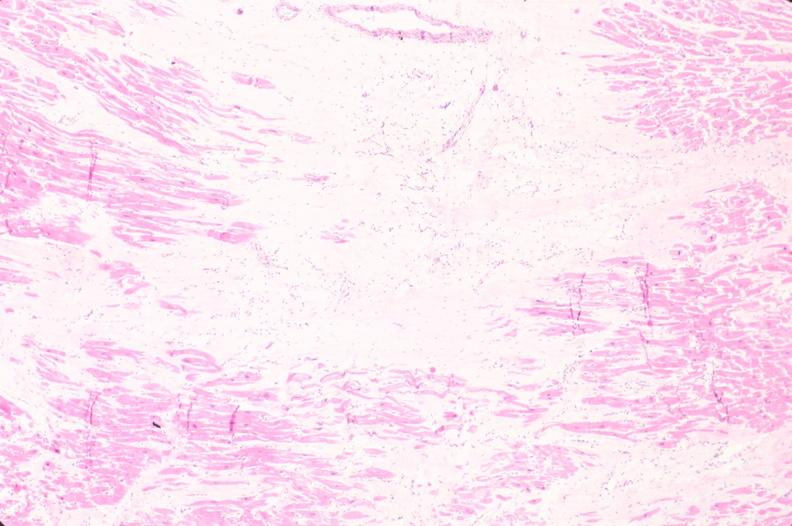does mesentery show heart, old myocardial infarction with fibrosis, he?
Answer the question using a single word or phrase. No 